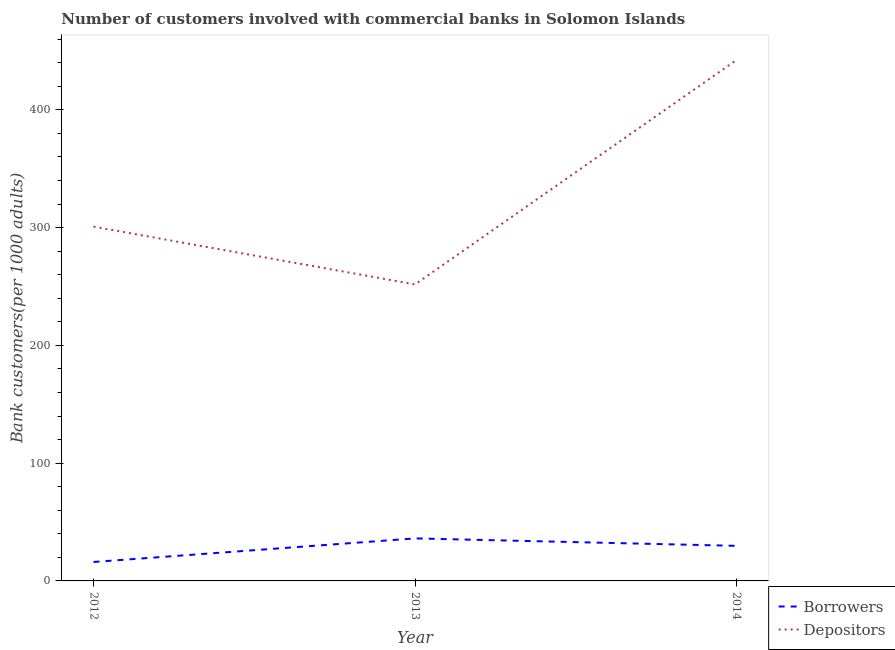How many different coloured lines are there?
Your answer should be compact. 2. Does the line corresponding to number of depositors intersect with the line corresponding to number of borrowers?
Give a very brief answer. No. Is the number of lines equal to the number of legend labels?
Offer a very short reply. Yes. What is the number of borrowers in 2012?
Provide a succinct answer. 16.09. Across all years, what is the maximum number of borrowers?
Ensure brevity in your answer.  36.11. Across all years, what is the minimum number of depositors?
Your response must be concise. 251.79. In which year was the number of borrowers maximum?
Offer a very short reply. 2013. What is the total number of depositors in the graph?
Provide a succinct answer. 995.05. What is the difference between the number of borrowers in 2013 and that in 2014?
Provide a succinct answer. 6.33. What is the difference between the number of depositors in 2012 and the number of borrowers in 2014?
Your response must be concise. 271.09. What is the average number of depositors per year?
Ensure brevity in your answer.  331.68. In the year 2012, what is the difference between the number of depositors and number of borrowers?
Provide a short and direct response. 284.79. What is the ratio of the number of borrowers in 2012 to that in 2014?
Provide a short and direct response. 0.54. Is the number of borrowers in 2013 less than that in 2014?
Provide a short and direct response. No. Is the difference between the number of depositors in 2012 and 2014 greater than the difference between the number of borrowers in 2012 and 2014?
Make the answer very short. No. What is the difference between the highest and the second highest number of borrowers?
Keep it short and to the point. 6.33. What is the difference between the highest and the lowest number of borrowers?
Your response must be concise. 20.03. Is the number of borrowers strictly less than the number of depositors over the years?
Ensure brevity in your answer.  Yes. How many lines are there?
Make the answer very short. 2. How many years are there in the graph?
Your response must be concise. 3. What is the difference between two consecutive major ticks on the Y-axis?
Offer a very short reply. 100. Are the values on the major ticks of Y-axis written in scientific E-notation?
Provide a short and direct response. No. Does the graph contain grids?
Your answer should be very brief. No. Where does the legend appear in the graph?
Keep it short and to the point. Bottom right. How are the legend labels stacked?
Offer a very short reply. Vertical. What is the title of the graph?
Keep it short and to the point. Number of customers involved with commercial banks in Solomon Islands. What is the label or title of the X-axis?
Keep it short and to the point. Year. What is the label or title of the Y-axis?
Your response must be concise. Bank customers(per 1000 adults). What is the Bank customers(per 1000 adults) of Borrowers in 2012?
Your response must be concise. 16.09. What is the Bank customers(per 1000 adults) in Depositors in 2012?
Ensure brevity in your answer.  300.87. What is the Bank customers(per 1000 adults) in Borrowers in 2013?
Keep it short and to the point. 36.11. What is the Bank customers(per 1000 adults) of Depositors in 2013?
Your response must be concise. 251.79. What is the Bank customers(per 1000 adults) in Borrowers in 2014?
Offer a very short reply. 29.78. What is the Bank customers(per 1000 adults) in Depositors in 2014?
Offer a terse response. 442.39. Across all years, what is the maximum Bank customers(per 1000 adults) of Borrowers?
Your answer should be compact. 36.11. Across all years, what is the maximum Bank customers(per 1000 adults) of Depositors?
Make the answer very short. 442.39. Across all years, what is the minimum Bank customers(per 1000 adults) in Borrowers?
Give a very brief answer. 16.09. Across all years, what is the minimum Bank customers(per 1000 adults) in Depositors?
Offer a terse response. 251.79. What is the total Bank customers(per 1000 adults) in Borrowers in the graph?
Provide a short and direct response. 81.98. What is the total Bank customers(per 1000 adults) in Depositors in the graph?
Provide a succinct answer. 995.05. What is the difference between the Bank customers(per 1000 adults) of Borrowers in 2012 and that in 2013?
Your response must be concise. -20.03. What is the difference between the Bank customers(per 1000 adults) in Depositors in 2012 and that in 2013?
Offer a terse response. 49.08. What is the difference between the Bank customers(per 1000 adults) of Borrowers in 2012 and that in 2014?
Offer a very short reply. -13.69. What is the difference between the Bank customers(per 1000 adults) of Depositors in 2012 and that in 2014?
Offer a very short reply. -141.52. What is the difference between the Bank customers(per 1000 adults) in Borrowers in 2013 and that in 2014?
Offer a very short reply. 6.33. What is the difference between the Bank customers(per 1000 adults) of Depositors in 2013 and that in 2014?
Offer a very short reply. -190.6. What is the difference between the Bank customers(per 1000 adults) of Borrowers in 2012 and the Bank customers(per 1000 adults) of Depositors in 2013?
Provide a succinct answer. -235.7. What is the difference between the Bank customers(per 1000 adults) in Borrowers in 2012 and the Bank customers(per 1000 adults) in Depositors in 2014?
Offer a very short reply. -426.3. What is the difference between the Bank customers(per 1000 adults) of Borrowers in 2013 and the Bank customers(per 1000 adults) of Depositors in 2014?
Offer a terse response. -406.28. What is the average Bank customers(per 1000 adults) of Borrowers per year?
Offer a terse response. 27.33. What is the average Bank customers(per 1000 adults) of Depositors per year?
Your answer should be compact. 331.68. In the year 2012, what is the difference between the Bank customers(per 1000 adults) in Borrowers and Bank customers(per 1000 adults) in Depositors?
Ensure brevity in your answer.  -284.79. In the year 2013, what is the difference between the Bank customers(per 1000 adults) in Borrowers and Bank customers(per 1000 adults) in Depositors?
Your answer should be compact. -215.68. In the year 2014, what is the difference between the Bank customers(per 1000 adults) in Borrowers and Bank customers(per 1000 adults) in Depositors?
Make the answer very short. -412.61. What is the ratio of the Bank customers(per 1000 adults) in Borrowers in 2012 to that in 2013?
Make the answer very short. 0.45. What is the ratio of the Bank customers(per 1000 adults) in Depositors in 2012 to that in 2013?
Offer a very short reply. 1.19. What is the ratio of the Bank customers(per 1000 adults) in Borrowers in 2012 to that in 2014?
Your answer should be compact. 0.54. What is the ratio of the Bank customers(per 1000 adults) in Depositors in 2012 to that in 2014?
Your response must be concise. 0.68. What is the ratio of the Bank customers(per 1000 adults) in Borrowers in 2013 to that in 2014?
Your answer should be compact. 1.21. What is the ratio of the Bank customers(per 1000 adults) in Depositors in 2013 to that in 2014?
Offer a very short reply. 0.57. What is the difference between the highest and the second highest Bank customers(per 1000 adults) of Borrowers?
Your answer should be very brief. 6.33. What is the difference between the highest and the second highest Bank customers(per 1000 adults) of Depositors?
Keep it short and to the point. 141.52. What is the difference between the highest and the lowest Bank customers(per 1000 adults) in Borrowers?
Make the answer very short. 20.03. What is the difference between the highest and the lowest Bank customers(per 1000 adults) of Depositors?
Make the answer very short. 190.6. 